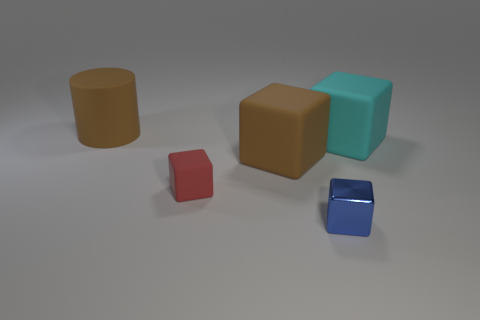Is there anything else that has the same shape as the tiny blue shiny object?
Ensure brevity in your answer.  Yes. There is a big rubber cylinder; is its color the same as the big rubber thing that is right of the blue metal block?
Provide a short and direct response. No. There is a small object that is right of the tiny matte block; what is its shape?
Keep it short and to the point. Cube. How many other things are the same material as the big cyan object?
Your response must be concise. 3. What is the big cyan thing made of?
Provide a succinct answer. Rubber. What number of tiny objects are blue metallic objects or gray rubber blocks?
Keep it short and to the point. 1. There is a large cyan thing; how many large cubes are in front of it?
Offer a terse response. 1. Are there any tiny metal cubes of the same color as the large cylinder?
Your answer should be very brief. No. What shape is the other object that is the same size as the blue metallic thing?
Offer a very short reply. Cube. How many yellow things are either cubes or balls?
Your answer should be compact. 0. 